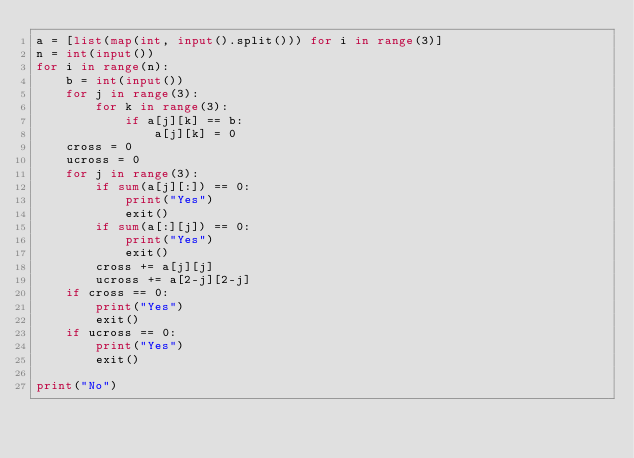Convert code to text. <code><loc_0><loc_0><loc_500><loc_500><_Python_>a = [list(map(int, input().split())) for i in range(3)]
n = int(input())
for i in range(n):
    b = int(input())
    for j in range(3):
        for k in range(3):
            if a[j][k] == b:
                a[j][k] = 0
    cross = 0
    ucross = 0
    for j in range(3):
        if sum(a[j][:]) == 0:
            print("Yes")
            exit()
        if sum(a[:][j]) == 0:
            print("Yes")
            exit()
        cross += a[j][j]
        ucross += a[2-j][2-j]
    if cross == 0:
        print("Yes")
        exit()
    if ucross == 0:
        print("Yes")
        exit()
         
print("No")</code> 